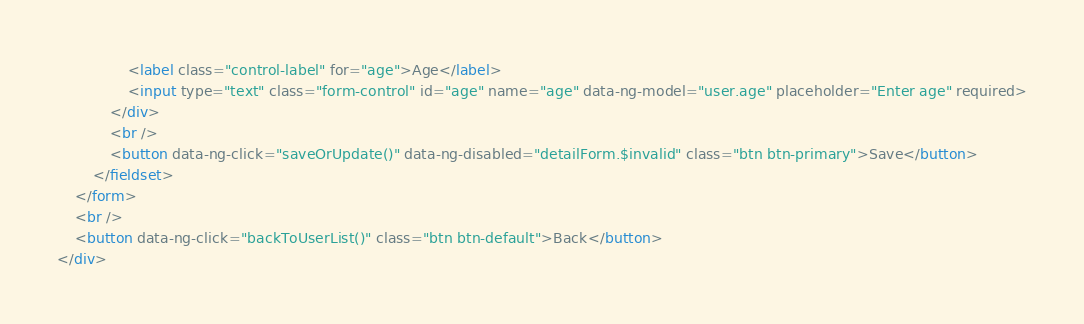Convert code to text. <code><loc_0><loc_0><loc_500><loc_500><_HTML_>				<label class="control-label" for="age">Age</label>
				<input type="text" class="form-control" id="age" name="age" data-ng-model="user.age" placeholder="Enter age" required>
			</div>
			<br />
			<button data-ng-click="saveOrUpdate()" data-ng-disabled="detailForm.$invalid" class="btn btn-primary">Save</button>
		</fieldset>
	</form>
	<br />
	<button data-ng-click="backToUserList()" class="btn btn-default">Back</button>
</div></code> 